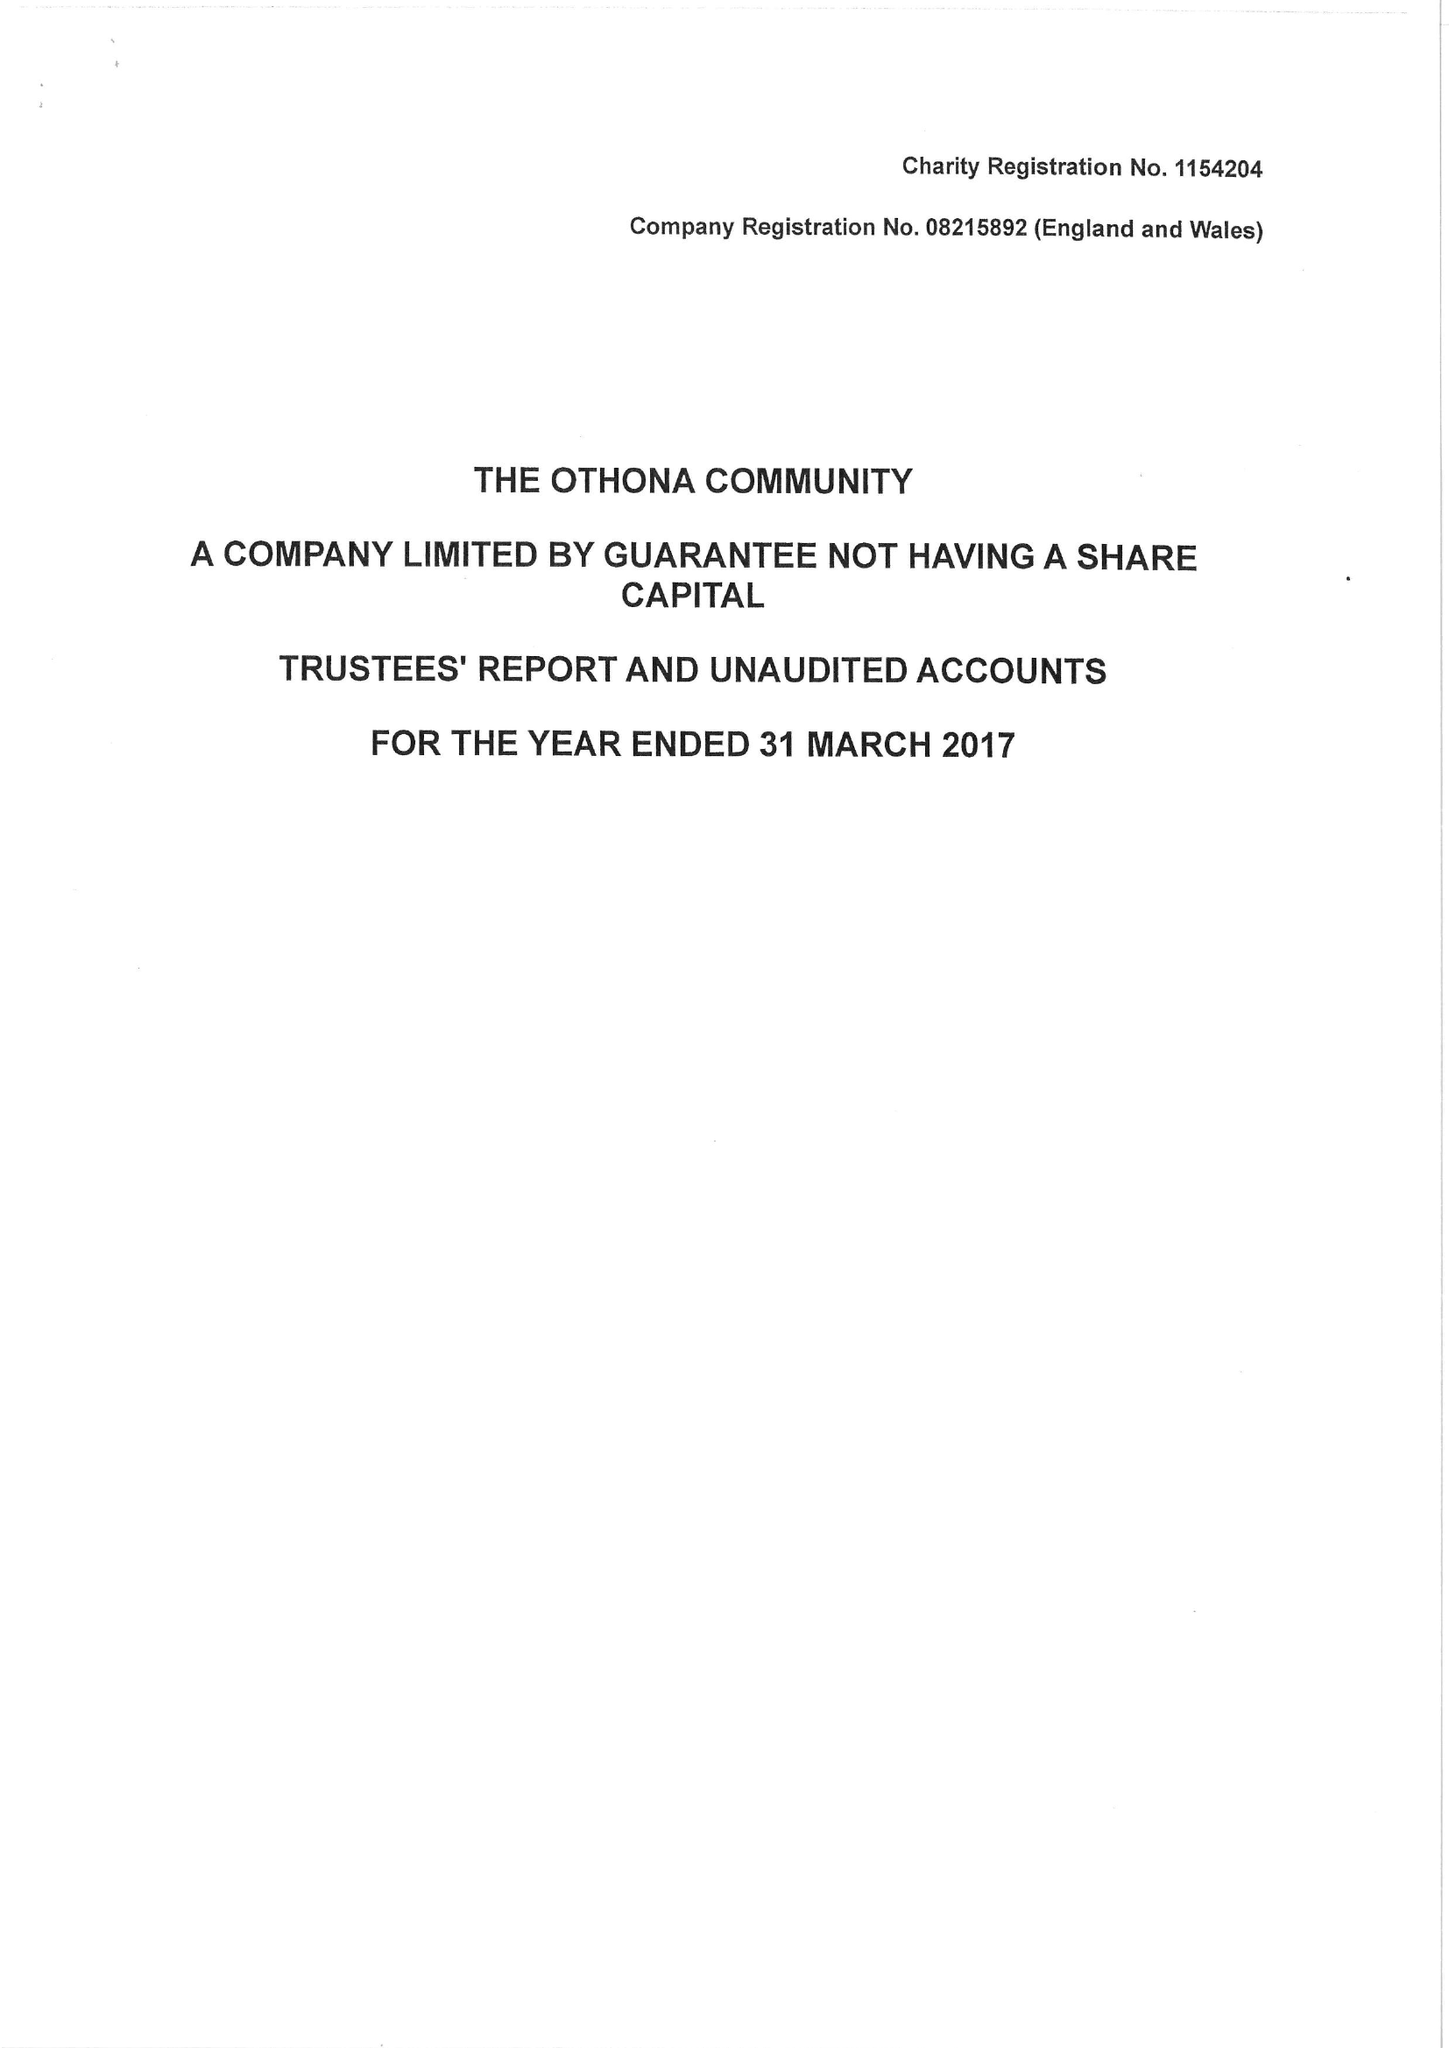What is the value for the address__street_line?
Answer the question using a single word or phrase. MILL END 